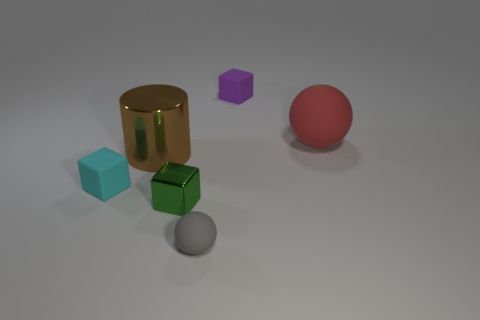There is a red object that is made of the same material as the tiny gray ball; what is its size?
Provide a succinct answer. Large. How many things are cyan cubes or small green cubes?
Offer a terse response. 2. There is a object that is on the left side of the metal cylinder; what color is it?
Keep it short and to the point. Cyan. What size is the purple rubber object that is the same shape as the tiny green object?
Make the answer very short. Small. What number of objects are either big things right of the small green block or tiny cubes in front of the large sphere?
Provide a short and direct response. 3. There is a matte object that is both on the right side of the gray sphere and to the left of the red thing; how big is it?
Ensure brevity in your answer.  Small. There is a brown thing; does it have the same shape as the rubber object on the right side of the tiny purple rubber cube?
Your answer should be compact. No. How many objects are either objects that are to the left of the red ball or small purple rubber blocks?
Offer a very short reply. 5. Do the tiny ball and the big object that is on the left side of the big red thing have the same material?
Provide a short and direct response. No. What shape is the matte thing behind the matte sphere that is to the right of the gray ball?
Your answer should be compact. Cube. 